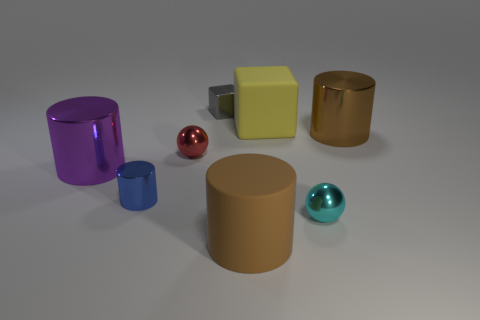What number of metal objects are in front of the large purple shiny object and on the right side of the tiny blue cylinder?
Provide a short and direct response. 1. There is a big brown cylinder on the left side of the brown cylinder behind the red metallic thing; are there any brown cylinders that are on the left side of it?
Offer a terse response. No. The matte object that is the same size as the yellow rubber block is what shape?
Offer a terse response. Cylinder. Are there any small cylinders of the same color as the big matte cube?
Give a very brief answer. No. Do the blue thing and the gray object have the same shape?
Your response must be concise. No. How many tiny things are either purple cylinders or gray shiny objects?
Your answer should be very brief. 1. What color is the cube that is the same material as the cyan sphere?
Keep it short and to the point. Gray. How many yellow blocks are made of the same material as the small cyan thing?
Make the answer very short. 0. There is a metallic cylinder behind the red sphere; is its size the same as the ball to the left of the small gray metal object?
Offer a terse response. No. What material is the large cylinder right of the large brown thing in front of the tiny red ball?
Your answer should be very brief. Metal. 